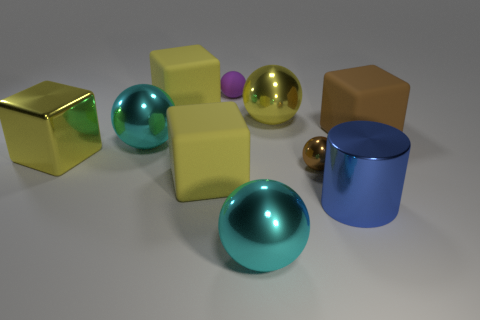Subtract all yellow cubes. How many were subtracted if there are1yellow cubes left? 2 Subtract all small shiny spheres. How many spheres are left? 4 Subtract all gray blocks. How many cyan spheres are left? 2 Subtract all brown cubes. How many cubes are left? 3 Subtract 1 blocks. How many blocks are left? 3 Subtract all cubes. How many objects are left? 6 Add 5 large rubber cubes. How many large rubber cubes are left? 8 Add 7 big cyan spheres. How many big cyan spheres exist? 9 Subtract 1 cyan spheres. How many objects are left? 9 Subtract all red balls. Subtract all green cubes. How many balls are left? 5 